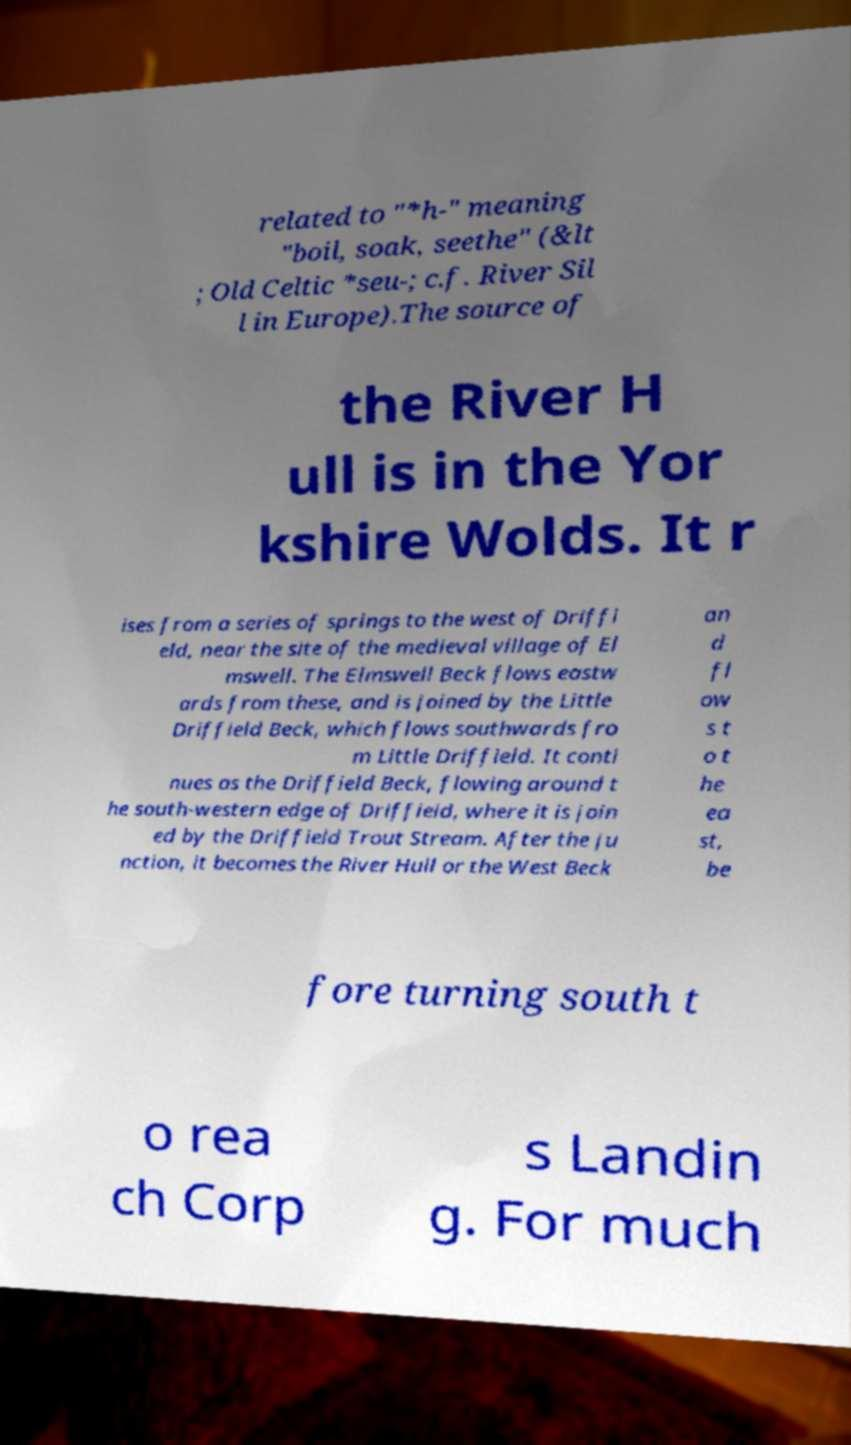For documentation purposes, I need the text within this image transcribed. Could you provide that? related to "*h-" meaning "boil, soak, seethe" (&lt ; Old Celtic *seu-; c.f. River Sil l in Europe).The source of the River H ull is in the Yor kshire Wolds. It r ises from a series of springs to the west of Driffi eld, near the site of the medieval village of El mswell. The Elmswell Beck flows eastw ards from these, and is joined by the Little Driffield Beck, which flows southwards fro m Little Driffield. It conti nues as the Driffield Beck, flowing around t he south-western edge of Driffield, where it is join ed by the Driffield Trout Stream. After the ju nction, it becomes the River Hull or the West Beck an d fl ow s t o t he ea st, be fore turning south t o rea ch Corp s Landin g. For much 